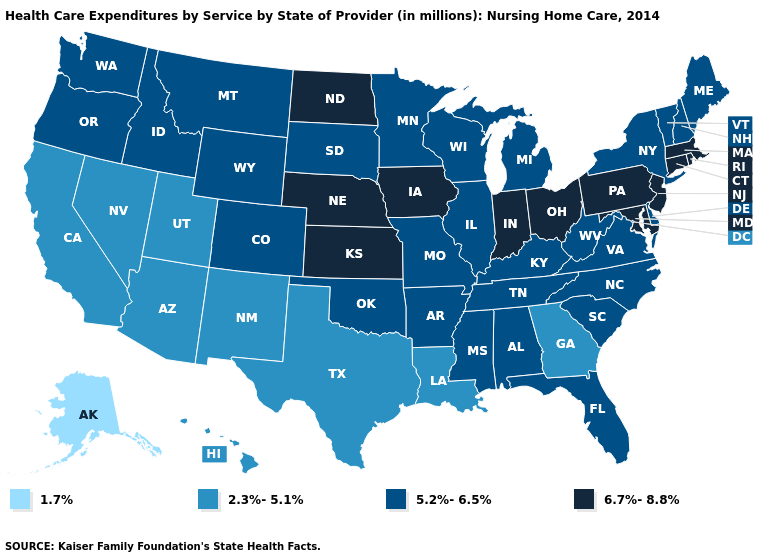Name the states that have a value in the range 1.7%?
Short answer required. Alaska. What is the highest value in states that border Alabama?
Give a very brief answer. 5.2%-6.5%. What is the value of Indiana?
Keep it brief. 6.7%-8.8%. Does Hawaii have a higher value than Delaware?
Quick response, please. No. What is the value of Connecticut?
Write a very short answer. 6.7%-8.8%. What is the value of Michigan?
Be succinct. 5.2%-6.5%. Name the states that have a value in the range 2.3%-5.1%?
Be succinct. Arizona, California, Georgia, Hawaii, Louisiana, Nevada, New Mexico, Texas, Utah. Among the states that border Pennsylvania , which have the lowest value?
Quick response, please. Delaware, New York, West Virginia. Among the states that border Virginia , which have the highest value?
Give a very brief answer. Maryland. Is the legend a continuous bar?
Keep it brief. No. Which states have the highest value in the USA?
Answer briefly. Connecticut, Indiana, Iowa, Kansas, Maryland, Massachusetts, Nebraska, New Jersey, North Dakota, Ohio, Pennsylvania, Rhode Island. What is the value of Montana?
Write a very short answer. 5.2%-6.5%. Is the legend a continuous bar?
Be succinct. No. Name the states that have a value in the range 2.3%-5.1%?
Answer briefly. Arizona, California, Georgia, Hawaii, Louisiana, Nevada, New Mexico, Texas, Utah. Does the map have missing data?
Write a very short answer. No. 